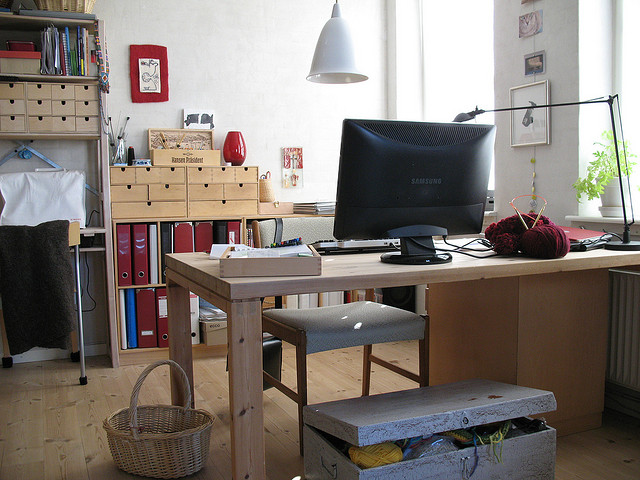<image>Is the desk lamp turned on? I am not sure if the desk lamp is turned on or not. However, most observations suggest that it is not. Is the desk lamp turned on? The desk lamp is not turned on. 